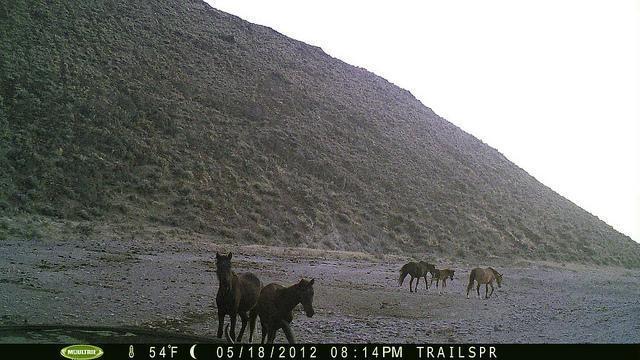How many horses are facing towards the camera?
Give a very brief answer. 2. How many horses are there?
Give a very brief answer. 2. How many black dogs are there?
Give a very brief answer. 0. 